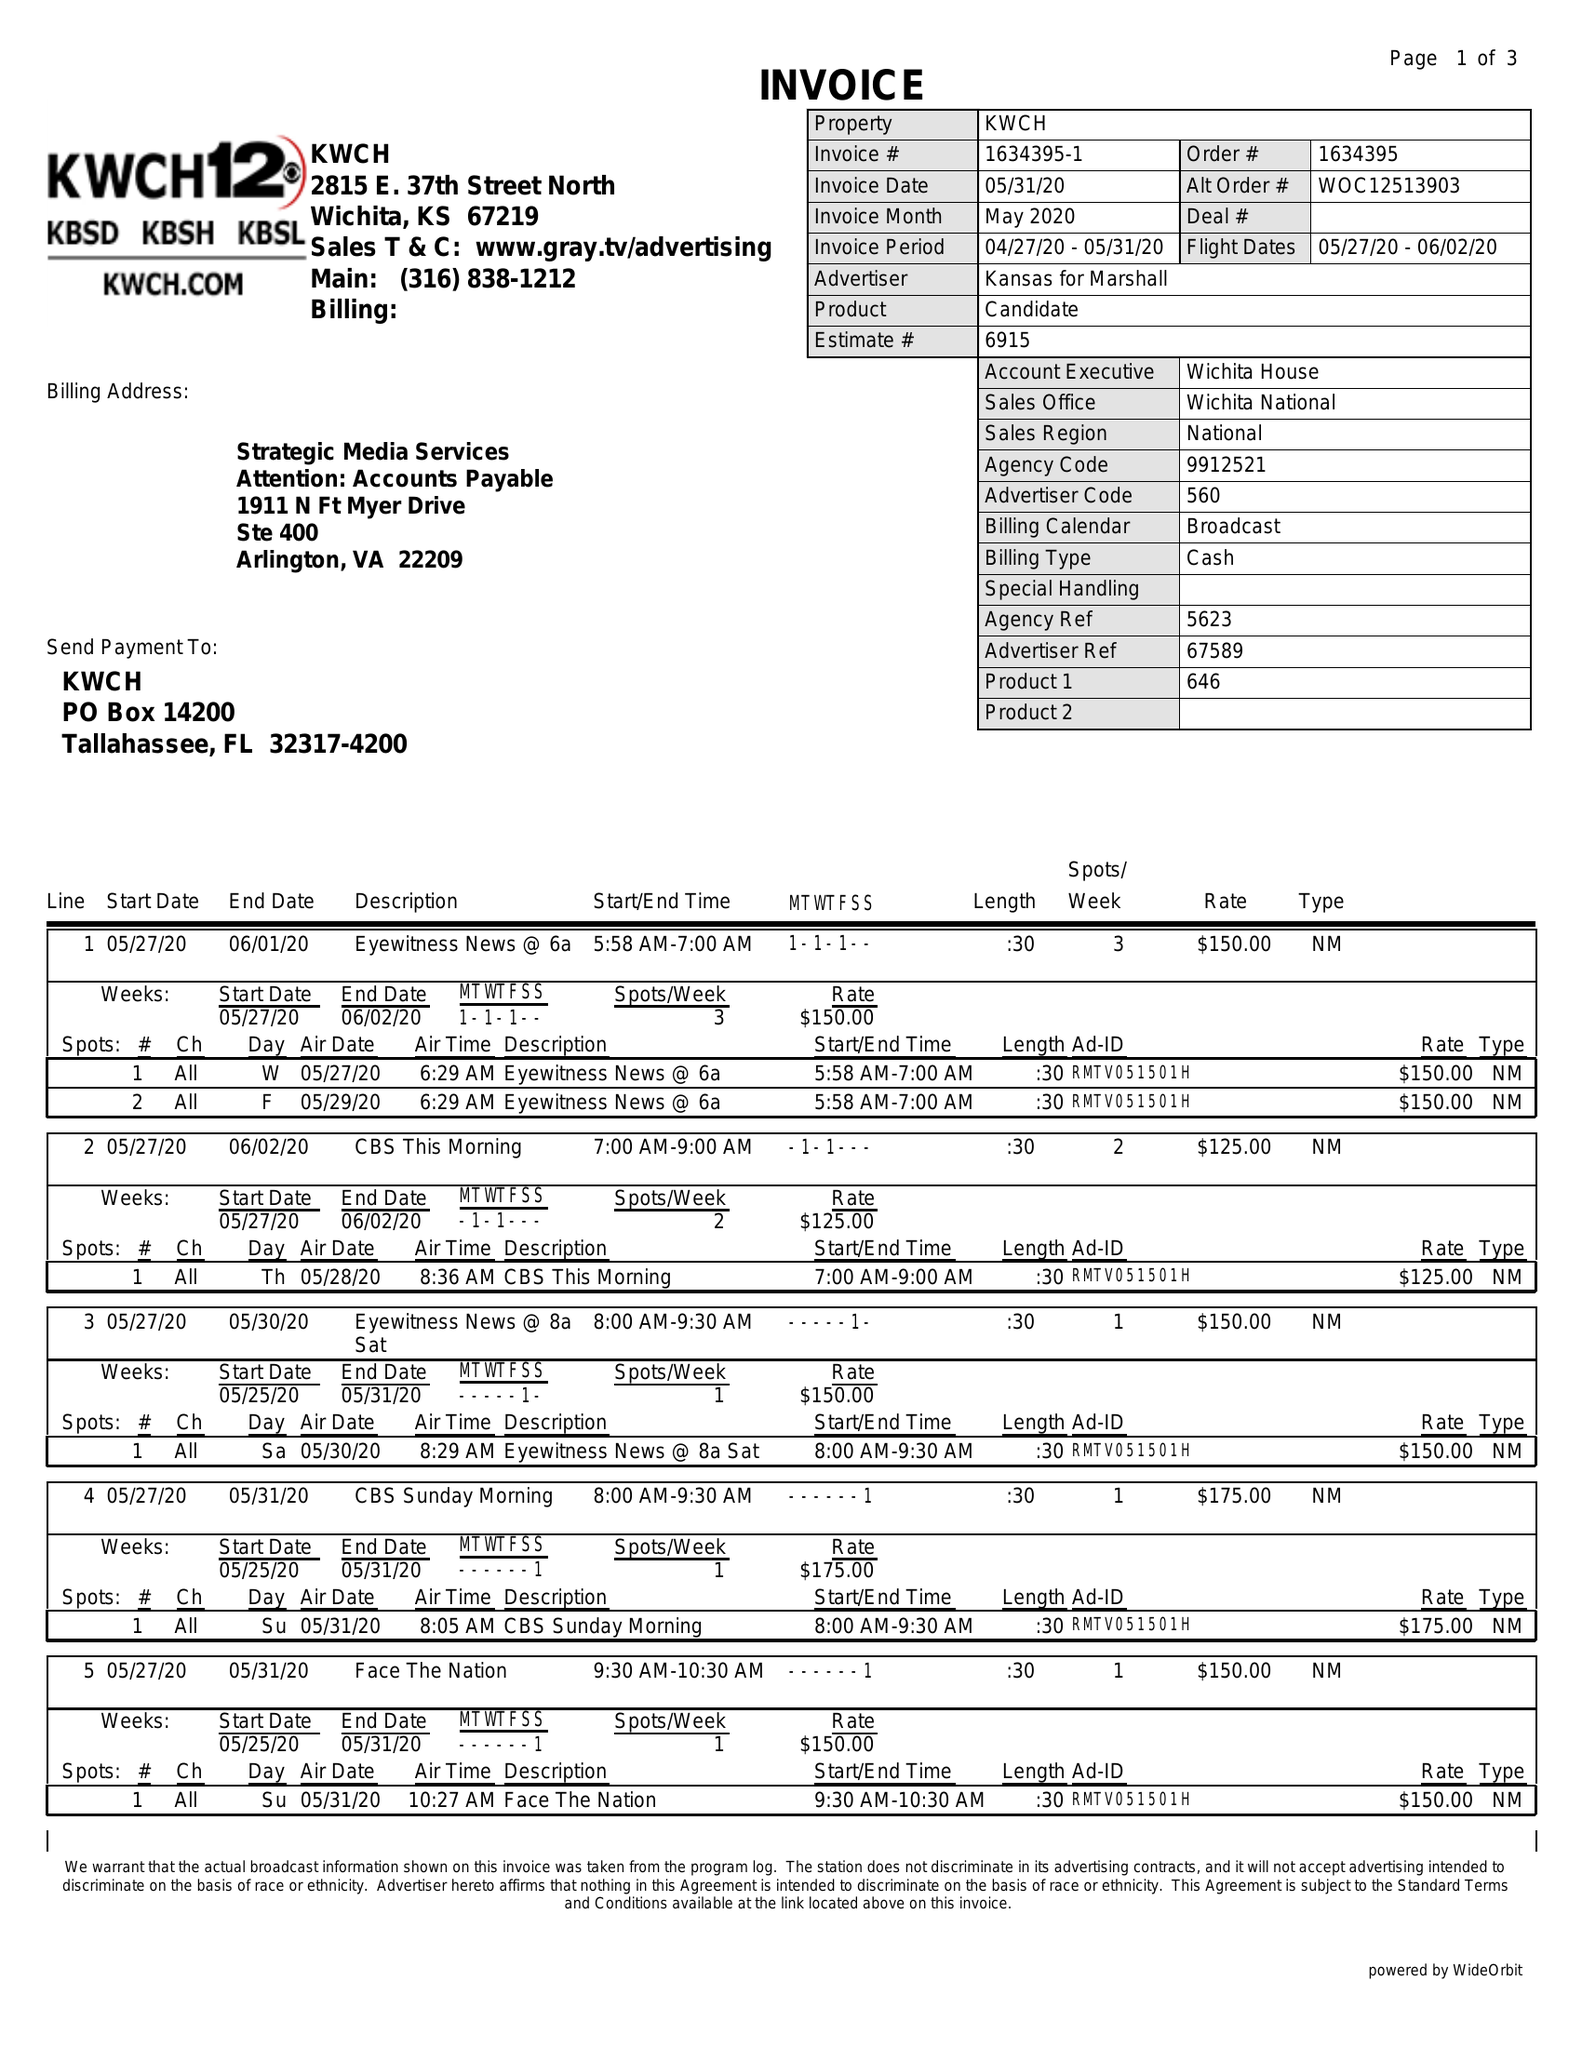What is the value for the advertiser?
Answer the question using a single word or phrase. KANSAS FOR MARSHALL 